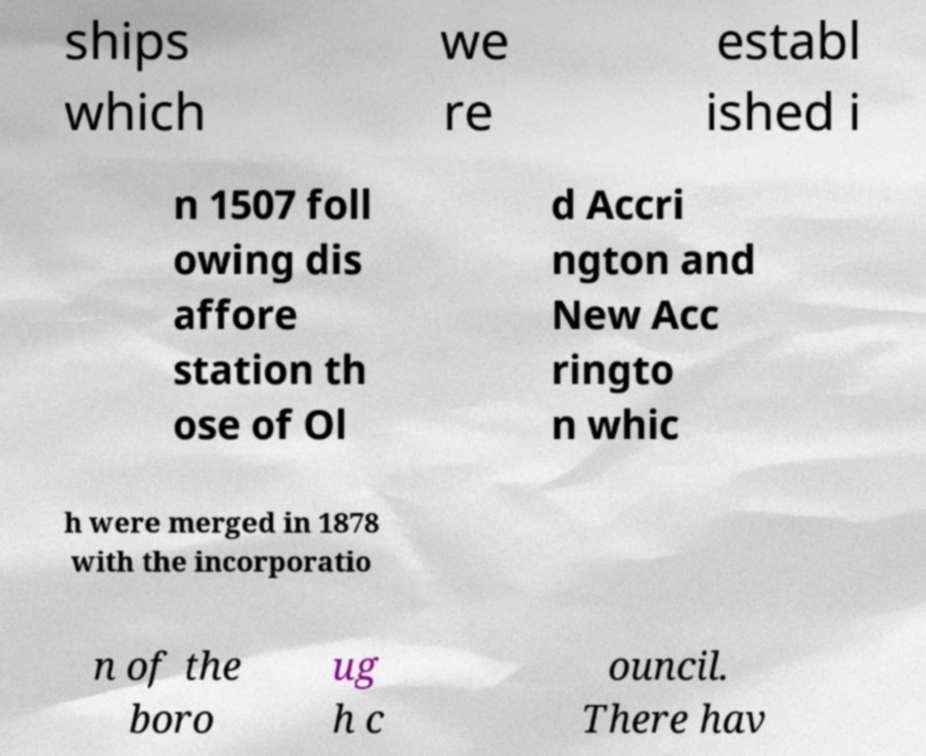I need the written content from this picture converted into text. Can you do that? ships which we re establ ished i n 1507 foll owing dis affore station th ose of Ol d Accri ngton and New Acc ringto n whic h were merged in 1878 with the incorporatio n of the boro ug h c ouncil. There hav 